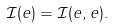Convert formula to latex. <formula><loc_0><loc_0><loc_500><loc_500>\mathcal { I } ( e ) = \mathcal { I } ( e , e ) .</formula> 